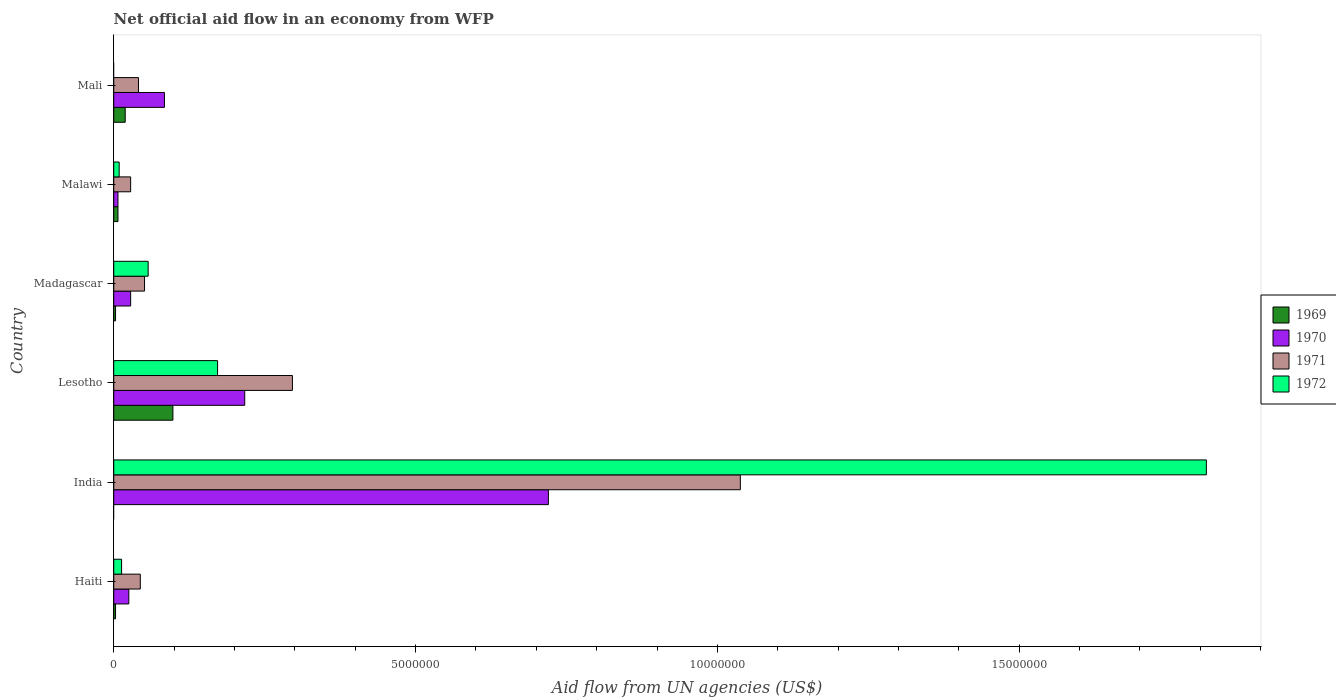How many different coloured bars are there?
Provide a short and direct response. 4. How many groups of bars are there?
Keep it short and to the point. 6. Are the number of bars per tick equal to the number of legend labels?
Provide a succinct answer. No. How many bars are there on the 6th tick from the bottom?
Offer a terse response. 3. What is the label of the 3rd group of bars from the top?
Your answer should be very brief. Madagascar. What is the net official aid flow in 1970 in India?
Give a very brief answer. 7.20e+06. Across all countries, what is the maximum net official aid flow in 1970?
Make the answer very short. 7.20e+06. In which country was the net official aid flow in 1970 maximum?
Keep it short and to the point. India. What is the total net official aid flow in 1969 in the graph?
Your response must be concise. 1.30e+06. What is the difference between the net official aid flow in 1970 in Lesotho and that in Mali?
Keep it short and to the point. 1.33e+06. What is the difference between the net official aid flow in 1970 in Mali and the net official aid flow in 1969 in Madagascar?
Your answer should be compact. 8.10e+05. What is the average net official aid flow in 1971 per country?
Provide a short and direct response. 2.50e+06. What is the difference between the net official aid flow in 1971 and net official aid flow in 1970 in Lesotho?
Give a very brief answer. 7.90e+05. In how many countries, is the net official aid flow in 1971 greater than 13000000 US$?
Your response must be concise. 0. What is the ratio of the net official aid flow in 1970 in Haiti to that in Lesotho?
Ensure brevity in your answer.  0.12. Is the net official aid flow in 1972 in Haiti less than that in Madagascar?
Offer a terse response. Yes. Is the difference between the net official aid flow in 1971 in India and Malawi greater than the difference between the net official aid flow in 1970 in India and Malawi?
Offer a very short reply. Yes. What is the difference between the highest and the second highest net official aid flow in 1972?
Provide a succinct answer. 1.64e+07. What is the difference between the highest and the lowest net official aid flow in 1972?
Provide a short and direct response. 1.81e+07. Is the sum of the net official aid flow in 1970 in Lesotho and Madagascar greater than the maximum net official aid flow in 1972 across all countries?
Offer a terse response. No. Is it the case that in every country, the sum of the net official aid flow in 1970 and net official aid flow in 1971 is greater than the net official aid flow in 1972?
Keep it short and to the point. No. Are all the bars in the graph horizontal?
Ensure brevity in your answer.  Yes. How many countries are there in the graph?
Give a very brief answer. 6. Are the values on the major ticks of X-axis written in scientific E-notation?
Your answer should be very brief. No. Does the graph contain grids?
Offer a very short reply. No. Where does the legend appear in the graph?
Ensure brevity in your answer.  Center right. How many legend labels are there?
Provide a short and direct response. 4. How are the legend labels stacked?
Your answer should be very brief. Vertical. What is the title of the graph?
Offer a terse response. Net official aid flow in an economy from WFP. What is the label or title of the X-axis?
Ensure brevity in your answer.  Aid flow from UN agencies (US$). What is the Aid flow from UN agencies (US$) in 1969 in Haiti?
Your answer should be very brief. 3.00e+04. What is the Aid flow from UN agencies (US$) in 1970 in Haiti?
Offer a terse response. 2.50e+05. What is the Aid flow from UN agencies (US$) in 1971 in Haiti?
Make the answer very short. 4.40e+05. What is the Aid flow from UN agencies (US$) in 1972 in Haiti?
Provide a succinct answer. 1.30e+05. What is the Aid flow from UN agencies (US$) in 1969 in India?
Offer a very short reply. 0. What is the Aid flow from UN agencies (US$) in 1970 in India?
Provide a succinct answer. 7.20e+06. What is the Aid flow from UN agencies (US$) in 1971 in India?
Keep it short and to the point. 1.04e+07. What is the Aid flow from UN agencies (US$) in 1972 in India?
Your response must be concise. 1.81e+07. What is the Aid flow from UN agencies (US$) of 1969 in Lesotho?
Offer a very short reply. 9.80e+05. What is the Aid flow from UN agencies (US$) in 1970 in Lesotho?
Give a very brief answer. 2.17e+06. What is the Aid flow from UN agencies (US$) in 1971 in Lesotho?
Your response must be concise. 2.96e+06. What is the Aid flow from UN agencies (US$) of 1972 in Lesotho?
Provide a succinct answer. 1.72e+06. What is the Aid flow from UN agencies (US$) in 1969 in Madagascar?
Provide a succinct answer. 3.00e+04. What is the Aid flow from UN agencies (US$) in 1970 in Madagascar?
Provide a succinct answer. 2.80e+05. What is the Aid flow from UN agencies (US$) in 1971 in Madagascar?
Provide a short and direct response. 5.10e+05. What is the Aid flow from UN agencies (US$) of 1972 in Madagascar?
Your response must be concise. 5.70e+05. What is the Aid flow from UN agencies (US$) in 1971 in Malawi?
Ensure brevity in your answer.  2.80e+05. What is the Aid flow from UN agencies (US$) of 1969 in Mali?
Your answer should be compact. 1.90e+05. What is the Aid flow from UN agencies (US$) of 1970 in Mali?
Offer a very short reply. 8.40e+05. What is the Aid flow from UN agencies (US$) in 1971 in Mali?
Offer a very short reply. 4.10e+05. Across all countries, what is the maximum Aid flow from UN agencies (US$) in 1969?
Your answer should be very brief. 9.80e+05. Across all countries, what is the maximum Aid flow from UN agencies (US$) in 1970?
Your response must be concise. 7.20e+06. Across all countries, what is the maximum Aid flow from UN agencies (US$) in 1971?
Offer a very short reply. 1.04e+07. Across all countries, what is the maximum Aid flow from UN agencies (US$) of 1972?
Provide a short and direct response. 1.81e+07. Across all countries, what is the minimum Aid flow from UN agencies (US$) of 1970?
Offer a very short reply. 7.00e+04. Across all countries, what is the minimum Aid flow from UN agencies (US$) of 1971?
Your answer should be very brief. 2.80e+05. What is the total Aid flow from UN agencies (US$) of 1969 in the graph?
Offer a terse response. 1.30e+06. What is the total Aid flow from UN agencies (US$) in 1970 in the graph?
Your answer should be compact. 1.08e+07. What is the total Aid flow from UN agencies (US$) of 1971 in the graph?
Your answer should be very brief. 1.50e+07. What is the total Aid flow from UN agencies (US$) in 1972 in the graph?
Keep it short and to the point. 2.06e+07. What is the difference between the Aid flow from UN agencies (US$) in 1970 in Haiti and that in India?
Your response must be concise. -6.95e+06. What is the difference between the Aid flow from UN agencies (US$) in 1971 in Haiti and that in India?
Your answer should be very brief. -9.94e+06. What is the difference between the Aid flow from UN agencies (US$) in 1972 in Haiti and that in India?
Provide a succinct answer. -1.80e+07. What is the difference between the Aid flow from UN agencies (US$) in 1969 in Haiti and that in Lesotho?
Ensure brevity in your answer.  -9.50e+05. What is the difference between the Aid flow from UN agencies (US$) of 1970 in Haiti and that in Lesotho?
Your answer should be very brief. -1.92e+06. What is the difference between the Aid flow from UN agencies (US$) in 1971 in Haiti and that in Lesotho?
Your answer should be very brief. -2.52e+06. What is the difference between the Aid flow from UN agencies (US$) of 1972 in Haiti and that in Lesotho?
Your answer should be very brief. -1.59e+06. What is the difference between the Aid flow from UN agencies (US$) of 1971 in Haiti and that in Madagascar?
Your response must be concise. -7.00e+04. What is the difference between the Aid flow from UN agencies (US$) in 1972 in Haiti and that in Madagascar?
Make the answer very short. -4.40e+05. What is the difference between the Aid flow from UN agencies (US$) of 1971 in Haiti and that in Malawi?
Ensure brevity in your answer.  1.60e+05. What is the difference between the Aid flow from UN agencies (US$) in 1972 in Haiti and that in Malawi?
Make the answer very short. 4.00e+04. What is the difference between the Aid flow from UN agencies (US$) in 1969 in Haiti and that in Mali?
Give a very brief answer. -1.60e+05. What is the difference between the Aid flow from UN agencies (US$) in 1970 in Haiti and that in Mali?
Provide a succinct answer. -5.90e+05. What is the difference between the Aid flow from UN agencies (US$) of 1971 in Haiti and that in Mali?
Give a very brief answer. 3.00e+04. What is the difference between the Aid flow from UN agencies (US$) in 1970 in India and that in Lesotho?
Provide a short and direct response. 5.03e+06. What is the difference between the Aid flow from UN agencies (US$) in 1971 in India and that in Lesotho?
Offer a terse response. 7.42e+06. What is the difference between the Aid flow from UN agencies (US$) in 1972 in India and that in Lesotho?
Provide a succinct answer. 1.64e+07. What is the difference between the Aid flow from UN agencies (US$) of 1970 in India and that in Madagascar?
Provide a short and direct response. 6.92e+06. What is the difference between the Aid flow from UN agencies (US$) of 1971 in India and that in Madagascar?
Ensure brevity in your answer.  9.87e+06. What is the difference between the Aid flow from UN agencies (US$) of 1972 in India and that in Madagascar?
Make the answer very short. 1.75e+07. What is the difference between the Aid flow from UN agencies (US$) in 1970 in India and that in Malawi?
Offer a very short reply. 7.13e+06. What is the difference between the Aid flow from UN agencies (US$) in 1971 in India and that in Malawi?
Make the answer very short. 1.01e+07. What is the difference between the Aid flow from UN agencies (US$) of 1972 in India and that in Malawi?
Make the answer very short. 1.80e+07. What is the difference between the Aid flow from UN agencies (US$) of 1970 in India and that in Mali?
Offer a very short reply. 6.36e+06. What is the difference between the Aid flow from UN agencies (US$) in 1971 in India and that in Mali?
Provide a short and direct response. 9.97e+06. What is the difference between the Aid flow from UN agencies (US$) of 1969 in Lesotho and that in Madagascar?
Provide a short and direct response. 9.50e+05. What is the difference between the Aid flow from UN agencies (US$) of 1970 in Lesotho and that in Madagascar?
Provide a short and direct response. 1.89e+06. What is the difference between the Aid flow from UN agencies (US$) of 1971 in Lesotho and that in Madagascar?
Provide a short and direct response. 2.45e+06. What is the difference between the Aid flow from UN agencies (US$) of 1972 in Lesotho and that in Madagascar?
Your answer should be compact. 1.15e+06. What is the difference between the Aid flow from UN agencies (US$) in 1969 in Lesotho and that in Malawi?
Your answer should be very brief. 9.10e+05. What is the difference between the Aid flow from UN agencies (US$) in 1970 in Lesotho and that in Malawi?
Make the answer very short. 2.10e+06. What is the difference between the Aid flow from UN agencies (US$) of 1971 in Lesotho and that in Malawi?
Give a very brief answer. 2.68e+06. What is the difference between the Aid flow from UN agencies (US$) in 1972 in Lesotho and that in Malawi?
Keep it short and to the point. 1.63e+06. What is the difference between the Aid flow from UN agencies (US$) of 1969 in Lesotho and that in Mali?
Offer a terse response. 7.90e+05. What is the difference between the Aid flow from UN agencies (US$) in 1970 in Lesotho and that in Mali?
Keep it short and to the point. 1.33e+06. What is the difference between the Aid flow from UN agencies (US$) of 1971 in Lesotho and that in Mali?
Your answer should be very brief. 2.55e+06. What is the difference between the Aid flow from UN agencies (US$) in 1969 in Madagascar and that in Malawi?
Your response must be concise. -4.00e+04. What is the difference between the Aid flow from UN agencies (US$) in 1970 in Madagascar and that in Malawi?
Make the answer very short. 2.10e+05. What is the difference between the Aid flow from UN agencies (US$) in 1970 in Madagascar and that in Mali?
Ensure brevity in your answer.  -5.60e+05. What is the difference between the Aid flow from UN agencies (US$) in 1969 in Malawi and that in Mali?
Your answer should be compact. -1.20e+05. What is the difference between the Aid flow from UN agencies (US$) in 1970 in Malawi and that in Mali?
Your answer should be compact. -7.70e+05. What is the difference between the Aid flow from UN agencies (US$) of 1971 in Malawi and that in Mali?
Provide a short and direct response. -1.30e+05. What is the difference between the Aid flow from UN agencies (US$) in 1969 in Haiti and the Aid flow from UN agencies (US$) in 1970 in India?
Provide a succinct answer. -7.17e+06. What is the difference between the Aid flow from UN agencies (US$) in 1969 in Haiti and the Aid flow from UN agencies (US$) in 1971 in India?
Your answer should be compact. -1.04e+07. What is the difference between the Aid flow from UN agencies (US$) of 1969 in Haiti and the Aid flow from UN agencies (US$) of 1972 in India?
Your answer should be very brief. -1.81e+07. What is the difference between the Aid flow from UN agencies (US$) of 1970 in Haiti and the Aid flow from UN agencies (US$) of 1971 in India?
Your answer should be very brief. -1.01e+07. What is the difference between the Aid flow from UN agencies (US$) of 1970 in Haiti and the Aid flow from UN agencies (US$) of 1972 in India?
Offer a terse response. -1.78e+07. What is the difference between the Aid flow from UN agencies (US$) of 1971 in Haiti and the Aid flow from UN agencies (US$) of 1972 in India?
Ensure brevity in your answer.  -1.77e+07. What is the difference between the Aid flow from UN agencies (US$) of 1969 in Haiti and the Aid flow from UN agencies (US$) of 1970 in Lesotho?
Provide a succinct answer. -2.14e+06. What is the difference between the Aid flow from UN agencies (US$) in 1969 in Haiti and the Aid flow from UN agencies (US$) in 1971 in Lesotho?
Offer a very short reply. -2.93e+06. What is the difference between the Aid flow from UN agencies (US$) of 1969 in Haiti and the Aid flow from UN agencies (US$) of 1972 in Lesotho?
Keep it short and to the point. -1.69e+06. What is the difference between the Aid flow from UN agencies (US$) of 1970 in Haiti and the Aid flow from UN agencies (US$) of 1971 in Lesotho?
Your answer should be compact. -2.71e+06. What is the difference between the Aid flow from UN agencies (US$) of 1970 in Haiti and the Aid flow from UN agencies (US$) of 1972 in Lesotho?
Provide a short and direct response. -1.47e+06. What is the difference between the Aid flow from UN agencies (US$) in 1971 in Haiti and the Aid flow from UN agencies (US$) in 1972 in Lesotho?
Provide a short and direct response. -1.28e+06. What is the difference between the Aid flow from UN agencies (US$) of 1969 in Haiti and the Aid flow from UN agencies (US$) of 1970 in Madagascar?
Make the answer very short. -2.50e+05. What is the difference between the Aid flow from UN agencies (US$) in 1969 in Haiti and the Aid flow from UN agencies (US$) in 1971 in Madagascar?
Make the answer very short. -4.80e+05. What is the difference between the Aid flow from UN agencies (US$) of 1969 in Haiti and the Aid flow from UN agencies (US$) of 1972 in Madagascar?
Your response must be concise. -5.40e+05. What is the difference between the Aid flow from UN agencies (US$) in 1970 in Haiti and the Aid flow from UN agencies (US$) in 1972 in Madagascar?
Make the answer very short. -3.20e+05. What is the difference between the Aid flow from UN agencies (US$) of 1971 in Haiti and the Aid flow from UN agencies (US$) of 1972 in Madagascar?
Your answer should be very brief. -1.30e+05. What is the difference between the Aid flow from UN agencies (US$) of 1969 in Haiti and the Aid flow from UN agencies (US$) of 1971 in Malawi?
Give a very brief answer. -2.50e+05. What is the difference between the Aid flow from UN agencies (US$) of 1969 in Haiti and the Aid flow from UN agencies (US$) of 1972 in Malawi?
Offer a very short reply. -6.00e+04. What is the difference between the Aid flow from UN agencies (US$) of 1970 in Haiti and the Aid flow from UN agencies (US$) of 1971 in Malawi?
Offer a very short reply. -3.00e+04. What is the difference between the Aid flow from UN agencies (US$) of 1970 in Haiti and the Aid flow from UN agencies (US$) of 1972 in Malawi?
Keep it short and to the point. 1.60e+05. What is the difference between the Aid flow from UN agencies (US$) of 1971 in Haiti and the Aid flow from UN agencies (US$) of 1972 in Malawi?
Provide a succinct answer. 3.50e+05. What is the difference between the Aid flow from UN agencies (US$) of 1969 in Haiti and the Aid flow from UN agencies (US$) of 1970 in Mali?
Your response must be concise. -8.10e+05. What is the difference between the Aid flow from UN agencies (US$) in 1969 in Haiti and the Aid flow from UN agencies (US$) in 1971 in Mali?
Offer a very short reply. -3.80e+05. What is the difference between the Aid flow from UN agencies (US$) of 1970 in India and the Aid flow from UN agencies (US$) of 1971 in Lesotho?
Provide a short and direct response. 4.24e+06. What is the difference between the Aid flow from UN agencies (US$) in 1970 in India and the Aid flow from UN agencies (US$) in 1972 in Lesotho?
Make the answer very short. 5.48e+06. What is the difference between the Aid flow from UN agencies (US$) in 1971 in India and the Aid flow from UN agencies (US$) in 1972 in Lesotho?
Ensure brevity in your answer.  8.66e+06. What is the difference between the Aid flow from UN agencies (US$) of 1970 in India and the Aid flow from UN agencies (US$) of 1971 in Madagascar?
Offer a very short reply. 6.69e+06. What is the difference between the Aid flow from UN agencies (US$) of 1970 in India and the Aid flow from UN agencies (US$) of 1972 in Madagascar?
Your response must be concise. 6.63e+06. What is the difference between the Aid flow from UN agencies (US$) in 1971 in India and the Aid flow from UN agencies (US$) in 1972 in Madagascar?
Provide a succinct answer. 9.81e+06. What is the difference between the Aid flow from UN agencies (US$) of 1970 in India and the Aid flow from UN agencies (US$) of 1971 in Malawi?
Your answer should be very brief. 6.92e+06. What is the difference between the Aid flow from UN agencies (US$) in 1970 in India and the Aid flow from UN agencies (US$) in 1972 in Malawi?
Offer a terse response. 7.11e+06. What is the difference between the Aid flow from UN agencies (US$) of 1971 in India and the Aid flow from UN agencies (US$) of 1972 in Malawi?
Offer a terse response. 1.03e+07. What is the difference between the Aid flow from UN agencies (US$) of 1970 in India and the Aid flow from UN agencies (US$) of 1971 in Mali?
Give a very brief answer. 6.79e+06. What is the difference between the Aid flow from UN agencies (US$) of 1969 in Lesotho and the Aid flow from UN agencies (US$) of 1970 in Madagascar?
Your answer should be very brief. 7.00e+05. What is the difference between the Aid flow from UN agencies (US$) in 1969 in Lesotho and the Aid flow from UN agencies (US$) in 1971 in Madagascar?
Keep it short and to the point. 4.70e+05. What is the difference between the Aid flow from UN agencies (US$) in 1970 in Lesotho and the Aid flow from UN agencies (US$) in 1971 in Madagascar?
Give a very brief answer. 1.66e+06. What is the difference between the Aid flow from UN agencies (US$) of 1970 in Lesotho and the Aid flow from UN agencies (US$) of 1972 in Madagascar?
Make the answer very short. 1.60e+06. What is the difference between the Aid flow from UN agencies (US$) of 1971 in Lesotho and the Aid flow from UN agencies (US$) of 1972 in Madagascar?
Give a very brief answer. 2.39e+06. What is the difference between the Aid flow from UN agencies (US$) in 1969 in Lesotho and the Aid flow from UN agencies (US$) in 1970 in Malawi?
Your response must be concise. 9.10e+05. What is the difference between the Aid flow from UN agencies (US$) in 1969 in Lesotho and the Aid flow from UN agencies (US$) in 1971 in Malawi?
Keep it short and to the point. 7.00e+05. What is the difference between the Aid flow from UN agencies (US$) of 1969 in Lesotho and the Aid flow from UN agencies (US$) of 1972 in Malawi?
Provide a succinct answer. 8.90e+05. What is the difference between the Aid flow from UN agencies (US$) in 1970 in Lesotho and the Aid flow from UN agencies (US$) in 1971 in Malawi?
Make the answer very short. 1.89e+06. What is the difference between the Aid flow from UN agencies (US$) in 1970 in Lesotho and the Aid flow from UN agencies (US$) in 1972 in Malawi?
Give a very brief answer. 2.08e+06. What is the difference between the Aid flow from UN agencies (US$) in 1971 in Lesotho and the Aid flow from UN agencies (US$) in 1972 in Malawi?
Provide a short and direct response. 2.87e+06. What is the difference between the Aid flow from UN agencies (US$) of 1969 in Lesotho and the Aid flow from UN agencies (US$) of 1971 in Mali?
Your answer should be very brief. 5.70e+05. What is the difference between the Aid flow from UN agencies (US$) in 1970 in Lesotho and the Aid flow from UN agencies (US$) in 1971 in Mali?
Offer a very short reply. 1.76e+06. What is the difference between the Aid flow from UN agencies (US$) of 1969 in Madagascar and the Aid flow from UN agencies (US$) of 1970 in Malawi?
Make the answer very short. -4.00e+04. What is the difference between the Aid flow from UN agencies (US$) of 1971 in Madagascar and the Aid flow from UN agencies (US$) of 1972 in Malawi?
Offer a terse response. 4.20e+05. What is the difference between the Aid flow from UN agencies (US$) in 1969 in Madagascar and the Aid flow from UN agencies (US$) in 1970 in Mali?
Your response must be concise. -8.10e+05. What is the difference between the Aid flow from UN agencies (US$) in 1969 in Madagascar and the Aid flow from UN agencies (US$) in 1971 in Mali?
Ensure brevity in your answer.  -3.80e+05. What is the difference between the Aid flow from UN agencies (US$) of 1970 in Madagascar and the Aid flow from UN agencies (US$) of 1971 in Mali?
Your answer should be very brief. -1.30e+05. What is the difference between the Aid flow from UN agencies (US$) of 1969 in Malawi and the Aid flow from UN agencies (US$) of 1970 in Mali?
Your answer should be compact. -7.70e+05. What is the difference between the Aid flow from UN agencies (US$) of 1969 in Malawi and the Aid flow from UN agencies (US$) of 1971 in Mali?
Provide a short and direct response. -3.40e+05. What is the average Aid flow from UN agencies (US$) in 1969 per country?
Provide a short and direct response. 2.17e+05. What is the average Aid flow from UN agencies (US$) of 1970 per country?
Make the answer very short. 1.80e+06. What is the average Aid flow from UN agencies (US$) in 1971 per country?
Give a very brief answer. 2.50e+06. What is the average Aid flow from UN agencies (US$) of 1972 per country?
Ensure brevity in your answer.  3.44e+06. What is the difference between the Aid flow from UN agencies (US$) in 1969 and Aid flow from UN agencies (US$) in 1970 in Haiti?
Ensure brevity in your answer.  -2.20e+05. What is the difference between the Aid flow from UN agencies (US$) of 1969 and Aid flow from UN agencies (US$) of 1971 in Haiti?
Offer a very short reply. -4.10e+05. What is the difference between the Aid flow from UN agencies (US$) in 1970 and Aid flow from UN agencies (US$) in 1972 in Haiti?
Make the answer very short. 1.20e+05. What is the difference between the Aid flow from UN agencies (US$) of 1971 and Aid flow from UN agencies (US$) of 1972 in Haiti?
Provide a short and direct response. 3.10e+05. What is the difference between the Aid flow from UN agencies (US$) in 1970 and Aid flow from UN agencies (US$) in 1971 in India?
Make the answer very short. -3.18e+06. What is the difference between the Aid flow from UN agencies (US$) of 1970 and Aid flow from UN agencies (US$) of 1972 in India?
Provide a succinct answer. -1.09e+07. What is the difference between the Aid flow from UN agencies (US$) in 1971 and Aid flow from UN agencies (US$) in 1972 in India?
Make the answer very short. -7.72e+06. What is the difference between the Aid flow from UN agencies (US$) of 1969 and Aid flow from UN agencies (US$) of 1970 in Lesotho?
Provide a succinct answer. -1.19e+06. What is the difference between the Aid flow from UN agencies (US$) of 1969 and Aid flow from UN agencies (US$) of 1971 in Lesotho?
Offer a terse response. -1.98e+06. What is the difference between the Aid flow from UN agencies (US$) in 1969 and Aid flow from UN agencies (US$) in 1972 in Lesotho?
Your answer should be very brief. -7.40e+05. What is the difference between the Aid flow from UN agencies (US$) of 1970 and Aid flow from UN agencies (US$) of 1971 in Lesotho?
Give a very brief answer. -7.90e+05. What is the difference between the Aid flow from UN agencies (US$) of 1971 and Aid flow from UN agencies (US$) of 1972 in Lesotho?
Make the answer very short. 1.24e+06. What is the difference between the Aid flow from UN agencies (US$) in 1969 and Aid flow from UN agencies (US$) in 1971 in Madagascar?
Ensure brevity in your answer.  -4.80e+05. What is the difference between the Aid flow from UN agencies (US$) of 1969 and Aid flow from UN agencies (US$) of 1972 in Madagascar?
Your response must be concise. -5.40e+05. What is the difference between the Aid flow from UN agencies (US$) of 1970 and Aid flow from UN agencies (US$) of 1971 in Madagascar?
Offer a terse response. -2.30e+05. What is the difference between the Aid flow from UN agencies (US$) in 1970 and Aid flow from UN agencies (US$) in 1972 in Madagascar?
Ensure brevity in your answer.  -2.90e+05. What is the difference between the Aid flow from UN agencies (US$) of 1970 and Aid flow from UN agencies (US$) of 1972 in Malawi?
Ensure brevity in your answer.  -2.00e+04. What is the difference between the Aid flow from UN agencies (US$) of 1971 and Aid flow from UN agencies (US$) of 1972 in Malawi?
Keep it short and to the point. 1.90e+05. What is the difference between the Aid flow from UN agencies (US$) in 1969 and Aid flow from UN agencies (US$) in 1970 in Mali?
Keep it short and to the point. -6.50e+05. What is the difference between the Aid flow from UN agencies (US$) of 1969 and Aid flow from UN agencies (US$) of 1971 in Mali?
Keep it short and to the point. -2.20e+05. What is the ratio of the Aid flow from UN agencies (US$) of 1970 in Haiti to that in India?
Provide a short and direct response. 0.03. What is the ratio of the Aid flow from UN agencies (US$) of 1971 in Haiti to that in India?
Ensure brevity in your answer.  0.04. What is the ratio of the Aid flow from UN agencies (US$) in 1972 in Haiti to that in India?
Offer a terse response. 0.01. What is the ratio of the Aid flow from UN agencies (US$) in 1969 in Haiti to that in Lesotho?
Offer a very short reply. 0.03. What is the ratio of the Aid flow from UN agencies (US$) in 1970 in Haiti to that in Lesotho?
Provide a short and direct response. 0.12. What is the ratio of the Aid flow from UN agencies (US$) in 1971 in Haiti to that in Lesotho?
Offer a terse response. 0.15. What is the ratio of the Aid flow from UN agencies (US$) of 1972 in Haiti to that in Lesotho?
Offer a very short reply. 0.08. What is the ratio of the Aid flow from UN agencies (US$) of 1970 in Haiti to that in Madagascar?
Offer a terse response. 0.89. What is the ratio of the Aid flow from UN agencies (US$) in 1971 in Haiti to that in Madagascar?
Provide a short and direct response. 0.86. What is the ratio of the Aid flow from UN agencies (US$) of 1972 in Haiti to that in Madagascar?
Your answer should be compact. 0.23. What is the ratio of the Aid flow from UN agencies (US$) in 1969 in Haiti to that in Malawi?
Offer a terse response. 0.43. What is the ratio of the Aid flow from UN agencies (US$) of 1970 in Haiti to that in Malawi?
Your answer should be compact. 3.57. What is the ratio of the Aid flow from UN agencies (US$) of 1971 in Haiti to that in Malawi?
Offer a very short reply. 1.57. What is the ratio of the Aid flow from UN agencies (US$) of 1972 in Haiti to that in Malawi?
Your answer should be compact. 1.44. What is the ratio of the Aid flow from UN agencies (US$) in 1969 in Haiti to that in Mali?
Give a very brief answer. 0.16. What is the ratio of the Aid flow from UN agencies (US$) of 1970 in Haiti to that in Mali?
Give a very brief answer. 0.3. What is the ratio of the Aid flow from UN agencies (US$) in 1971 in Haiti to that in Mali?
Provide a short and direct response. 1.07. What is the ratio of the Aid flow from UN agencies (US$) in 1970 in India to that in Lesotho?
Ensure brevity in your answer.  3.32. What is the ratio of the Aid flow from UN agencies (US$) of 1971 in India to that in Lesotho?
Offer a very short reply. 3.51. What is the ratio of the Aid flow from UN agencies (US$) of 1972 in India to that in Lesotho?
Offer a terse response. 10.52. What is the ratio of the Aid flow from UN agencies (US$) in 1970 in India to that in Madagascar?
Your answer should be very brief. 25.71. What is the ratio of the Aid flow from UN agencies (US$) of 1971 in India to that in Madagascar?
Offer a very short reply. 20.35. What is the ratio of the Aid flow from UN agencies (US$) of 1972 in India to that in Madagascar?
Offer a terse response. 31.75. What is the ratio of the Aid flow from UN agencies (US$) of 1970 in India to that in Malawi?
Offer a very short reply. 102.86. What is the ratio of the Aid flow from UN agencies (US$) of 1971 in India to that in Malawi?
Offer a very short reply. 37.07. What is the ratio of the Aid flow from UN agencies (US$) of 1972 in India to that in Malawi?
Your answer should be compact. 201.11. What is the ratio of the Aid flow from UN agencies (US$) in 1970 in India to that in Mali?
Your response must be concise. 8.57. What is the ratio of the Aid flow from UN agencies (US$) of 1971 in India to that in Mali?
Your response must be concise. 25.32. What is the ratio of the Aid flow from UN agencies (US$) in 1969 in Lesotho to that in Madagascar?
Make the answer very short. 32.67. What is the ratio of the Aid flow from UN agencies (US$) in 1970 in Lesotho to that in Madagascar?
Your answer should be very brief. 7.75. What is the ratio of the Aid flow from UN agencies (US$) in 1971 in Lesotho to that in Madagascar?
Keep it short and to the point. 5.8. What is the ratio of the Aid flow from UN agencies (US$) in 1972 in Lesotho to that in Madagascar?
Provide a succinct answer. 3.02. What is the ratio of the Aid flow from UN agencies (US$) in 1969 in Lesotho to that in Malawi?
Provide a short and direct response. 14. What is the ratio of the Aid flow from UN agencies (US$) of 1970 in Lesotho to that in Malawi?
Offer a terse response. 31. What is the ratio of the Aid flow from UN agencies (US$) of 1971 in Lesotho to that in Malawi?
Your answer should be very brief. 10.57. What is the ratio of the Aid flow from UN agencies (US$) of 1972 in Lesotho to that in Malawi?
Keep it short and to the point. 19.11. What is the ratio of the Aid flow from UN agencies (US$) in 1969 in Lesotho to that in Mali?
Provide a short and direct response. 5.16. What is the ratio of the Aid flow from UN agencies (US$) of 1970 in Lesotho to that in Mali?
Give a very brief answer. 2.58. What is the ratio of the Aid flow from UN agencies (US$) of 1971 in Lesotho to that in Mali?
Provide a short and direct response. 7.22. What is the ratio of the Aid flow from UN agencies (US$) of 1969 in Madagascar to that in Malawi?
Offer a terse response. 0.43. What is the ratio of the Aid flow from UN agencies (US$) of 1971 in Madagascar to that in Malawi?
Make the answer very short. 1.82. What is the ratio of the Aid flow from UN agencies (US$) in 1972 in Madagascar to that in Malawi?
Your answer should be compact. 6.33. What is the ratio of the Aid flow from UN agencies (US$) of 1969 in Madagascar to that in Mali?
Make the answer very short. 0.16. What is the ratio of the Aid flow from UN agencies (US$) of 1971 in Madagascar to that in Mali?
Offer a very short reply. 1.24. What is the ratio of the Aid flow from UN agencies (US$) in 1969 in Malawi to that in Mali?
Keep it short and to the point. 0.37. What is the ratio of the Aid flow from UN agencies (US$) in 1970 in Malawi to that in Mali?
Your response must be concise. 0.08. What is the ratio of the Aid flow from UN agencies (US$) in 1971 in Malawi to that in Mali?
Your response must be concise. 0.68. What is the difference between the highest and the second highest Aid flow from UN agencies (US$) of 1969?
Keep it short and to the point. 7.90e+05. What is the difference between the highest and the second highest Aid flow from UN agencies (US$) in 1970?
Offer a terse response. 5.03e+06. What is the difference between the highest and the second highest Aid flow from UN agencies (US$) of 1971?
Ensure brevity in your answer.  7.42e+06. What is the difference between the highest and the second highest Aid flow from UN agencies (US$) of 1972?
Your response must be concise. 1.64e+07. What is the difference between the highest and the lowest Aid flow from UN agencies (US$) of 1969?
Your answer should be very brief. 9.80e+05. What is the difference between the highest and the lowest Aid flow from UN agencies (US$) of 1970?
Your answer should be very brief. 7.13e+06. What is the difference between the highest and the lowest Aid flow from UN agencies (US$) of 1971?
Offer a terse response. 1.01e+07. What is the difference between the highest and the lowest Aid flow from UN agencies (US$) of 1972?
Provide a succinct answer. 1.81e+07. 